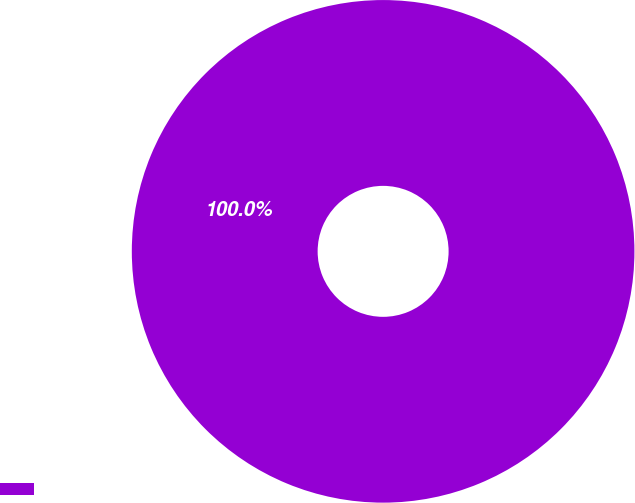<chart> <loc_0><loc_0><loc_500><loc_500><pie_chart><ecel><nl><fcel>100.0%<nl></chart> 